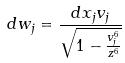Convert formula to latex. <formula><loc_0><loc_0><loc_500><loc_500>d w _ { j } = \frac { d x _ { j } v _ { j } } { \sqrt { 1 - \frac { v _ { j } ^ { 6 } } { z ^ { 6 } } } }</formula> 